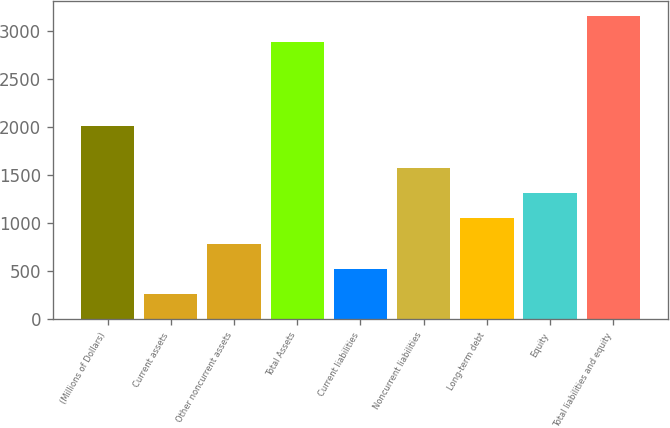Convert chart. <chart><loc_0><loc_0><loc_500><loc_500><bar_chart><fcel>(Millions of Dollars)<fcel>Current assets<fcel>Other noncurrent assets<fcel>Total Assets<fcel>Current liabilities<fcel>Noncurrent liabilities<fcel>Long-term debt<fcel>Equity<fcel>Total liabilities and equity<nl><fcel>2018<fcel>263<fcel>788.8<fcel>2892<fcel>525.9<fcel>1577.5<fcel>1051.7<fcel>1314.6<fcel>3154.9<nl></chart> 